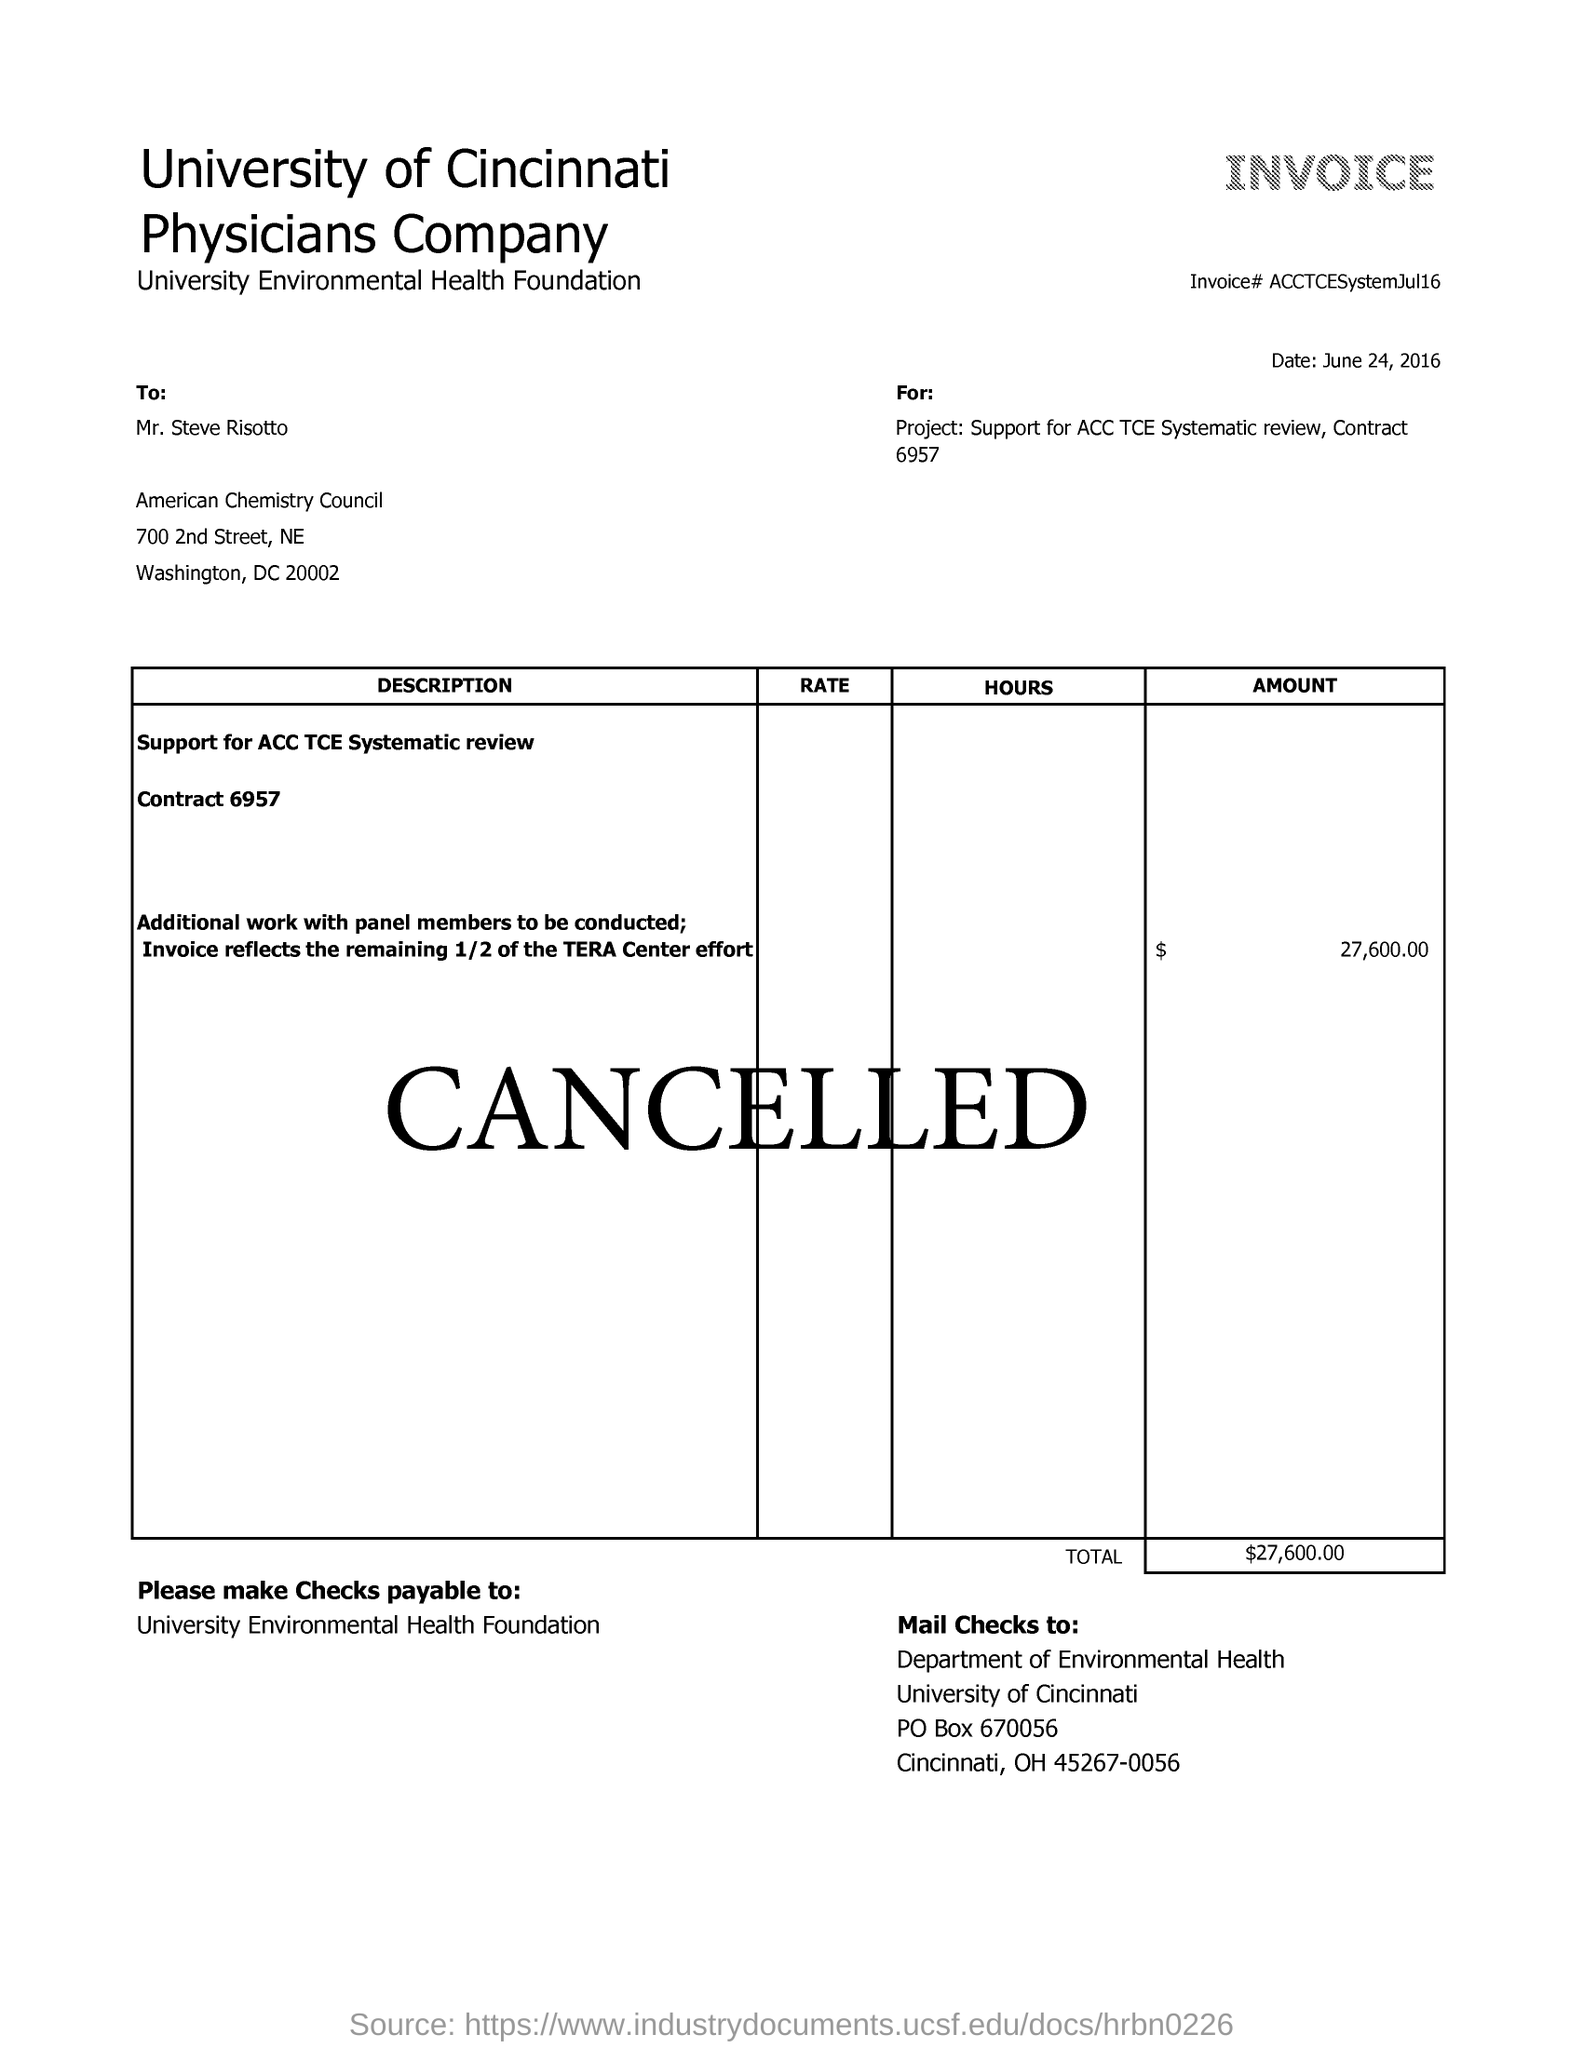Mention a couple of crucial points in this snapshot. The total amount of the invoice is two hundred and seventy-six thousand dollars and 00 cents. The invoice number is ACCTCESystemJul16. The date mentioned in the invoice is June 24, 2016. 